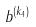<formula> <loc_0><loc_0><loc_500><loc_500>b ^ { ( k _ { 4 } ) }</formula> 